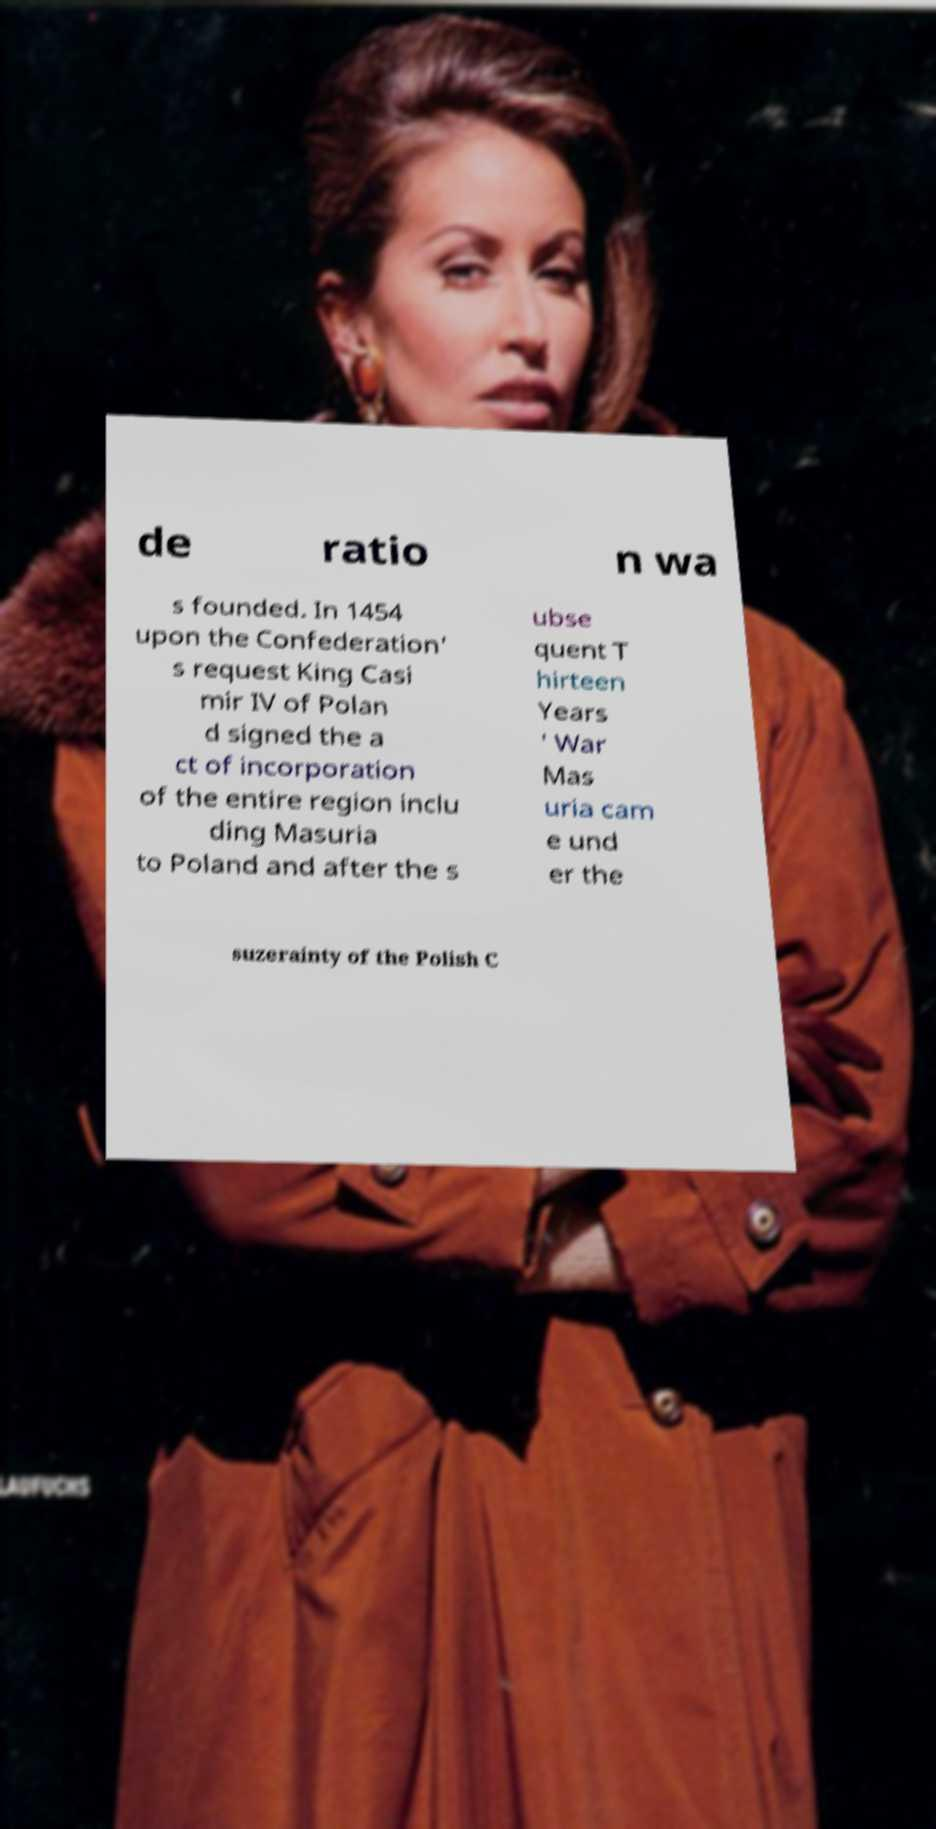There's text embedded in this image that I need extracted. Can you transcribe it verbatim? de ratio n wa s founded. In 1454 upon the Confederation' s request King Casi mir IV of Polan d signed the a ct of incorporation of the entire region inclu ding Masuria to Poland and after the s ubse quent T hirteen Years ' War Mas uria cam e und er the suzerainty of the Polish C 